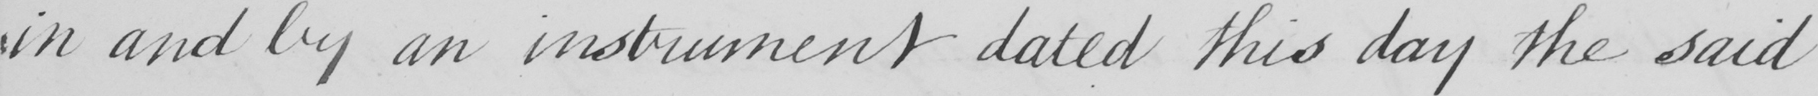What text is written in this handwritten line? in and by an instrument dated this day the said 